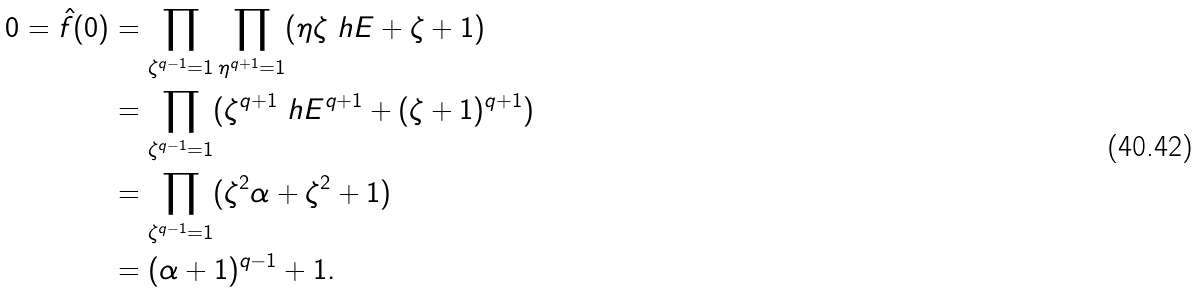Convert formula to latex. <formula><loc_0><loc_0><loc_500><loc_500>0 = \hat { f } ( 0 ) & = \prod _ { \zeta ^ { q - 1 } = 1 } \prod _ { \eta ^ { q + 1 } = 1 } ( \eta \zeta \ h E + \zeta + 1 ) \\ & = \prod _ { \zeta ^ { q - 1 } = 1 } ( \zeta ^ { q + 1 } \ h E ^ { q + 1 } + ( \zeta + 1 ) ^ { q + 1 } ) \\ & = \prod _ { \zeta ^ { q - 1 } = 1 } ( \zeta ^ { 2 } \alpha + \zeta ^ { 2 } + 1 ) \\ & = ( \alpha + 1 ) ^ { q - 1 } + 1 .</formula> 